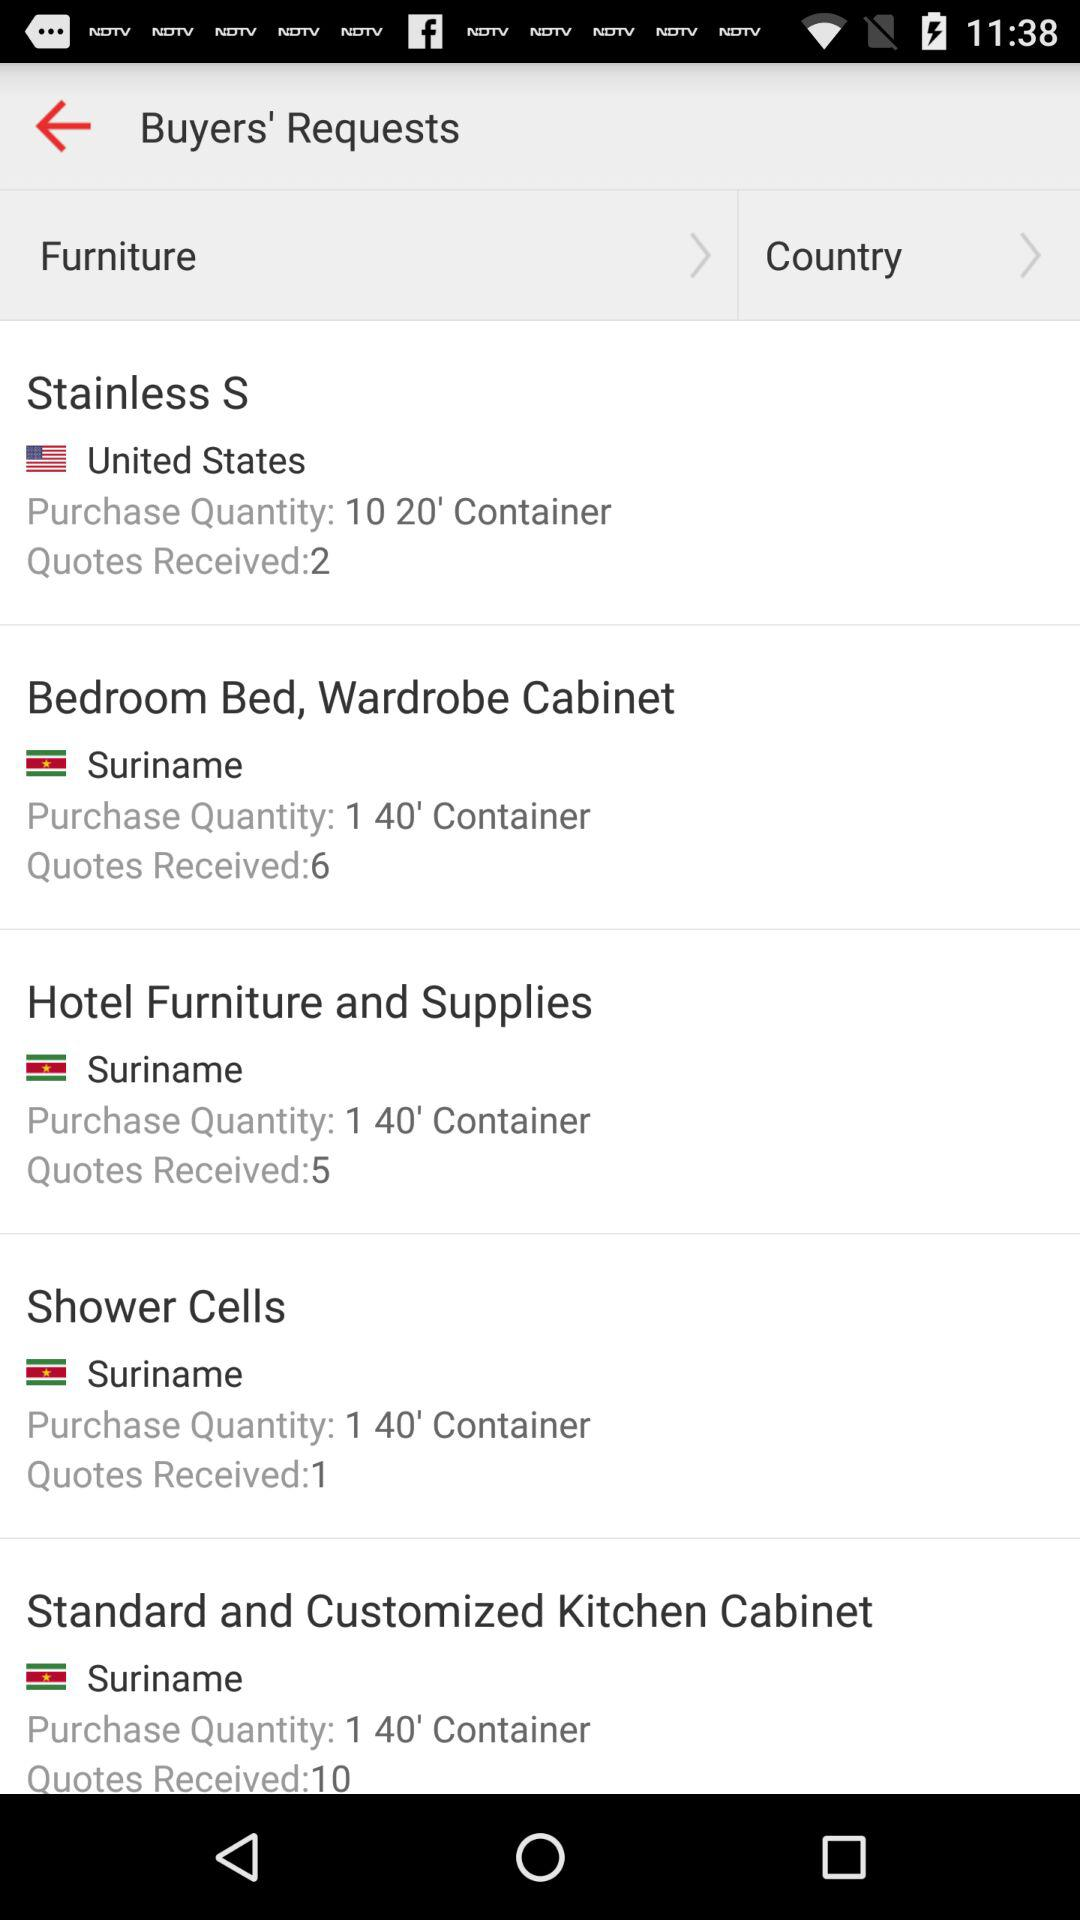How many more quotes were received for the Stainless S request than the Shower Cells request?
Answer the question using a single word or phrase. 1 